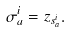<formula> <loc_0><loc_0><loc_500><loc_500>\sigma _ { a } ^ { i } = z _ { s _ { a } ^ { i } } .</formula> 